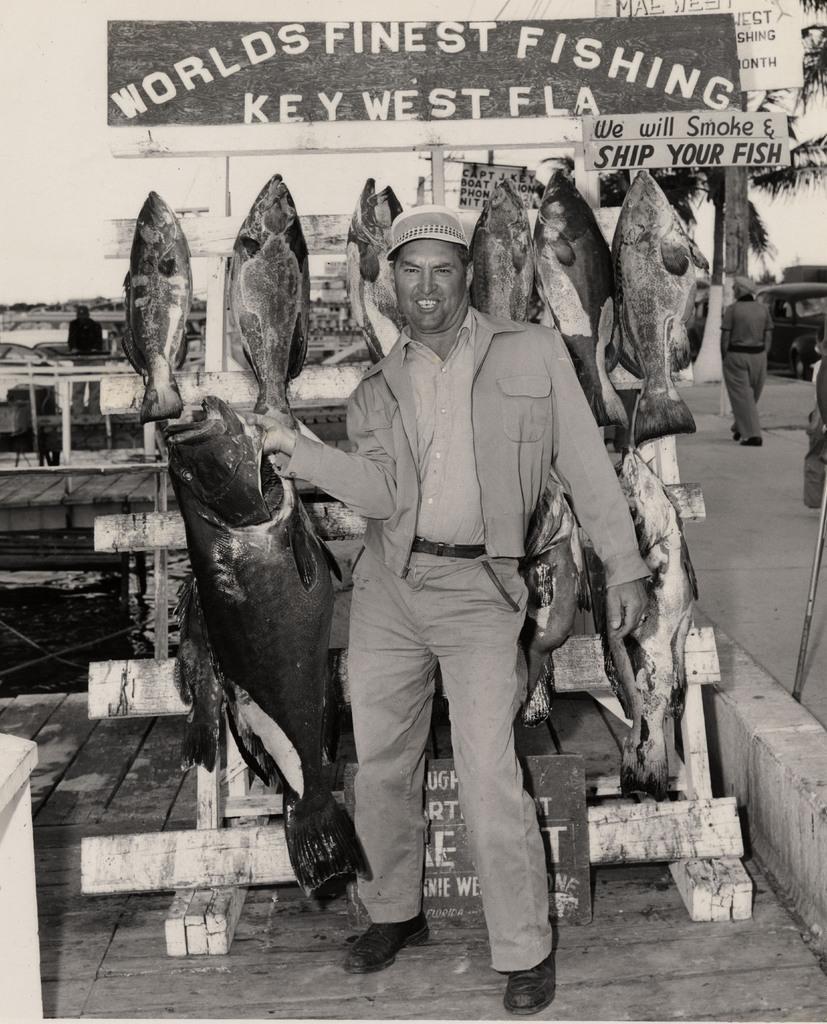Please provide a concise description of this image. I see this is a black and white image and I see a man over here who is smiling and I see that he is holding a fish and I see few more fishes over here and I see boards on which there is something written and I see the path and I see another person over here and I see a car over here. 